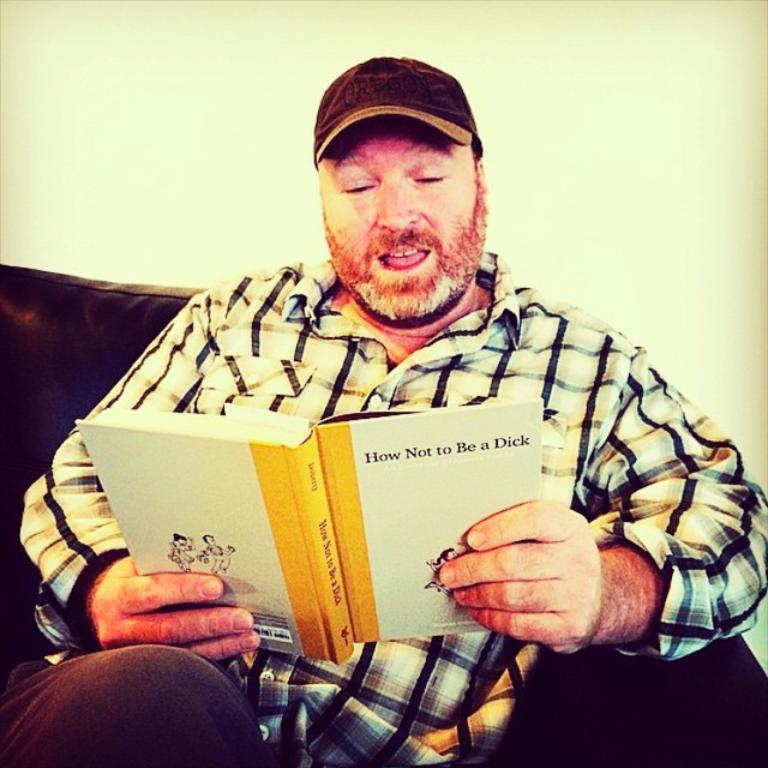Could you give a brief overview of what you see in this image? In the center of the image there is a person sitting in the sofa and holding a book. In the background there is a wall. 